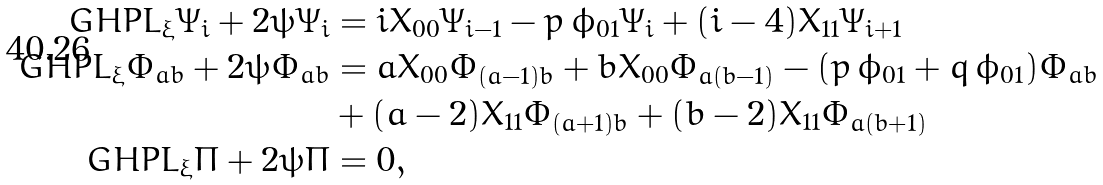Convert formula to latex. <formula><loc_0><loc_0><loc_500><loc_500>\ G H P L _ { \xi } \Psi _ { i } + 2 \psi \Psi _ { i } & = i X _ { 0 0 } \Psi _ { i - 1 } - p \, \phi _ { 0 1 } \Psi _ { i } + ( i - 4 ) X _ { 1 1 } \Psi _ { i + 1 } \\ \ G H P L _ { \xi } \Phi _ { a b } + 2 \psi \Phi _ { a b } & = a X _ { 0 0 } \Phi _ { ( a - 1 ) b } + b \bar { X } _ { 0 0 } \Phi _ { a ( b - 1 ) } - ( p \, \phi _ { 0 1 } + q \, \bar { \phi } _ { 0 1 } ) \Phi _ { a b } \\ & + ( a - 2 ) X _ { 1 1 } \Phi _ { ( a + 1 ) b } + ( b - 2 ) \bar { X } _ { 1 1 } \Phi _ { a ( b + 1 ) } \\ \ G H P L _ { \xi } \Pi + 2 \psi \Pi & = 0 ,</formula> 